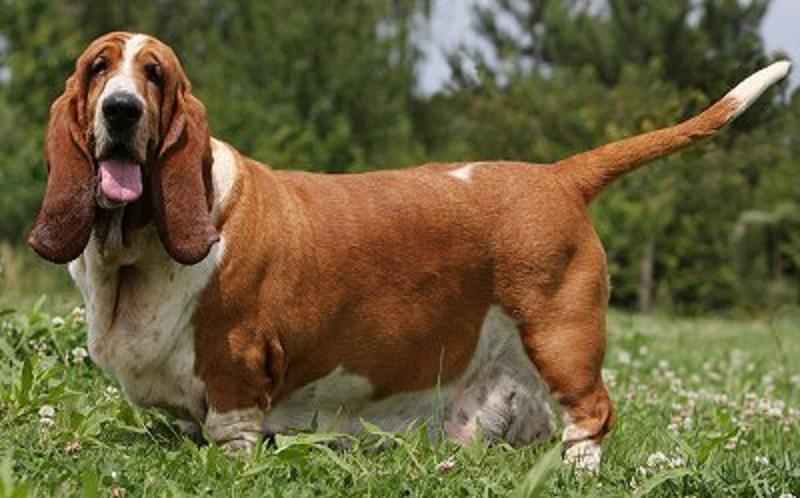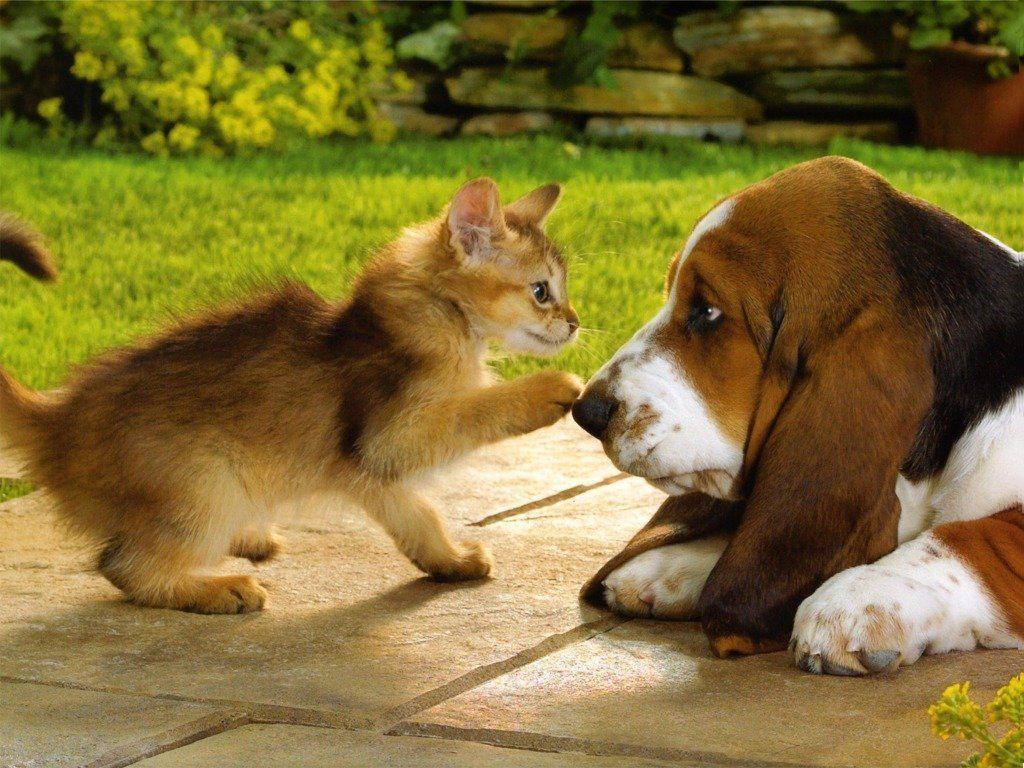The first image is the image on the left, the second image is the image on the right. Considering the images on both sides, is "One of the dogs is running in the grass." valid? Answer yes or no. No. 